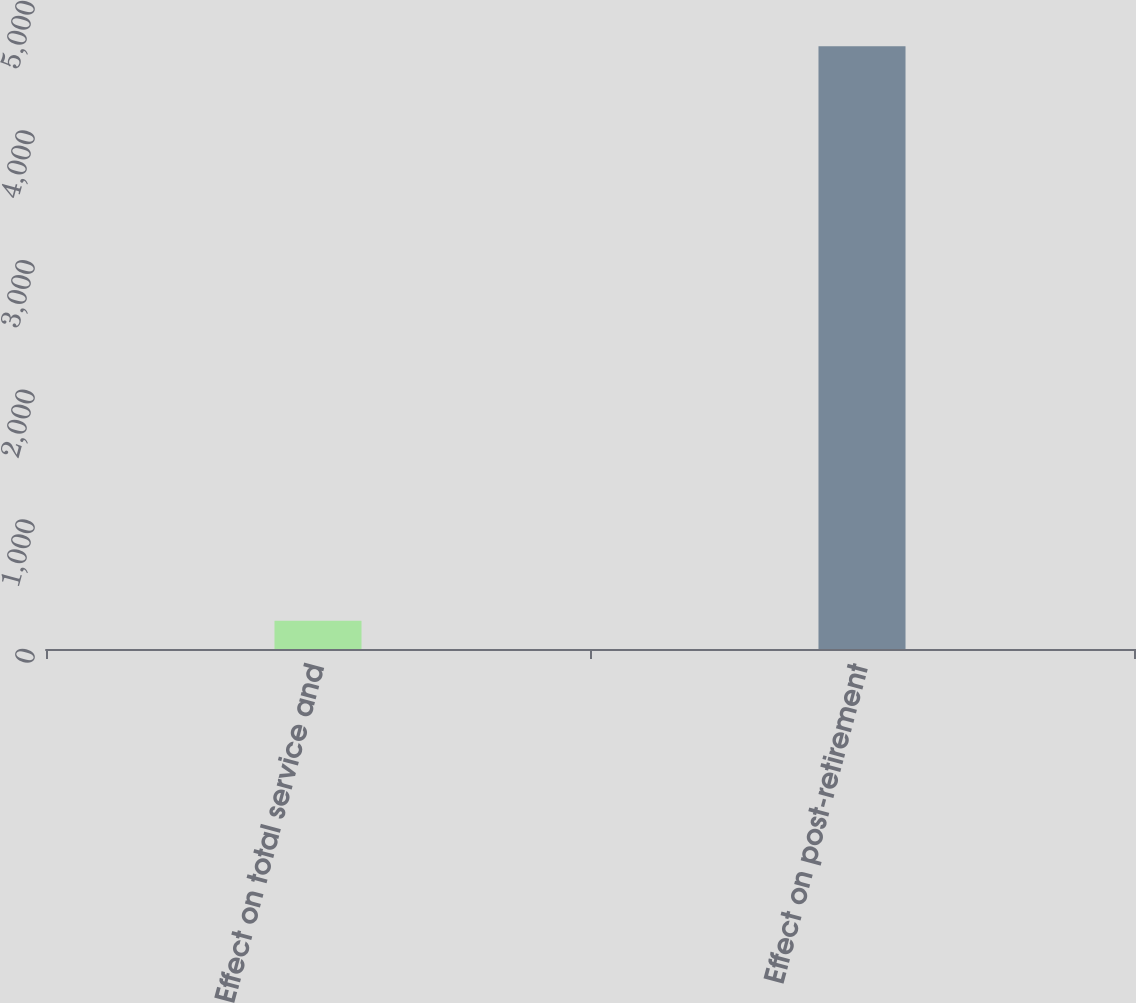Convert chart. <chart><loc_0><loc_0><loc_500><loc_500><bar_chart><fcel>Effect on total service and<fcel>Effect on post-retirement<nl><fcel>218<fcel>4650<nl></chart> 